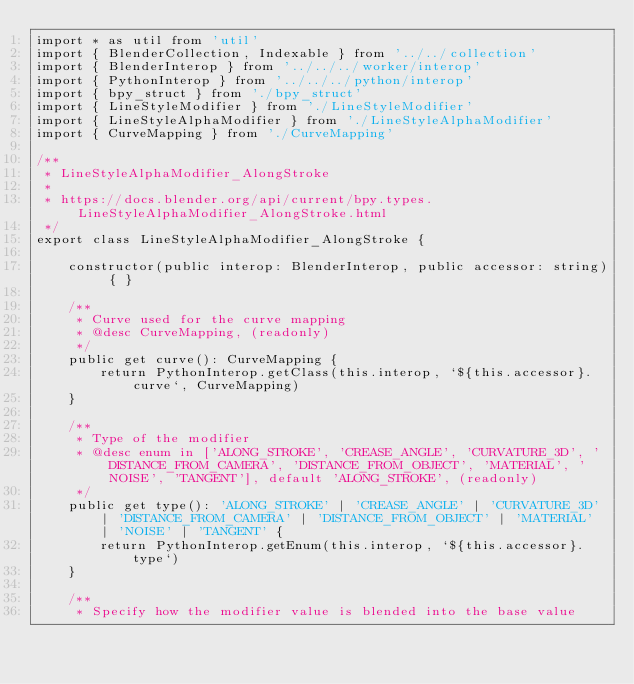<code> <loc_0><loc_0><loc_500><loc_500><_TypeScript_>import * as util from 'util'
import { BlenderCollection, Indexable } from '../../collection'
import { BlenderInterop } from '../../../worker/interop'
import { PythonInterop } from '../../../python/interop'
import { bpy_struct } from './bpy_struct'
import { LineStyleModifier } from './LineStyleModifier'
import { LineStyleAlphaModifier } from './LineStyleAlphaModifier'
import { CurveMapping } from './CurveMapping'

/**
 * LineStyleAlphaModifier_AlongStroke
 * 
 * https://docs.blender.org/api/current/bpy.types.LineStyleAlphaModifier_AlongStroke.html
 */
export class LineStyleAlphaModifier_AlongStroke {

    constructor(public interop: BlenderInterop, public accessor: string) { }

    /**
     * Curve used for the curve mapping
     * @desc CurveMapping, (readonly)
     */
    public get curve(): CurveMapping {
        return PythonInterop.getClass(this.interop, `${this.accessor}.curve`, CurveMapping)
    }

    /**
     * Type of the modifier
     * @desc enum in ['ALONG_STROKE', 'CREASE_ANGLE', 'CURVATURE_3D', 'DISTANCE_FROM_CAMERA', 'DISTANCE_FROM_OBJECT', 'MATERIAL', 'NOISE', 'TANGENT'], default 'ALONG_STROKE', (readonly)
     */
    public get type(): 'ALONG_STROKE' | 'CREASE_ANGLE' | 'CURVATURE_3D' | 'DISTANCE_FROM_CAMERA' | 'DISTANCE_FROM_OBJECT' | 'MATERIAL' | 'NOISE' | 'TANGENT' {
        return PythonInterop.getEnum(this.interop, `${this.accessor}.type`)
    }

    /**
     * Specify how the modifier value is blended into the base value</code> 